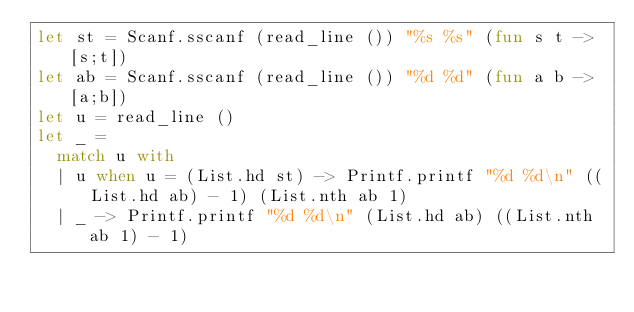<code> <loc_0><loc_0><loc_500><loc_500><_OCaml_>let st = Scanf.sscanf (read_line ()) "%s %s" (fun s t -> [s;t])
let ab = Scanf.sscanf (read_line ()) "%d %d" (fun a b -> [a;b])
let u = read_line ()
let _ = 
  match u with
  | u when u = (List.hd st) -> Printf.printf "%d %d\n" ((List.hd ab) - 1) (List.nth ab 1)
  | _ -> Printf.printf "%d %d\n" (List.hd ab) ((List.nth ab 1) - 1)


</code> 